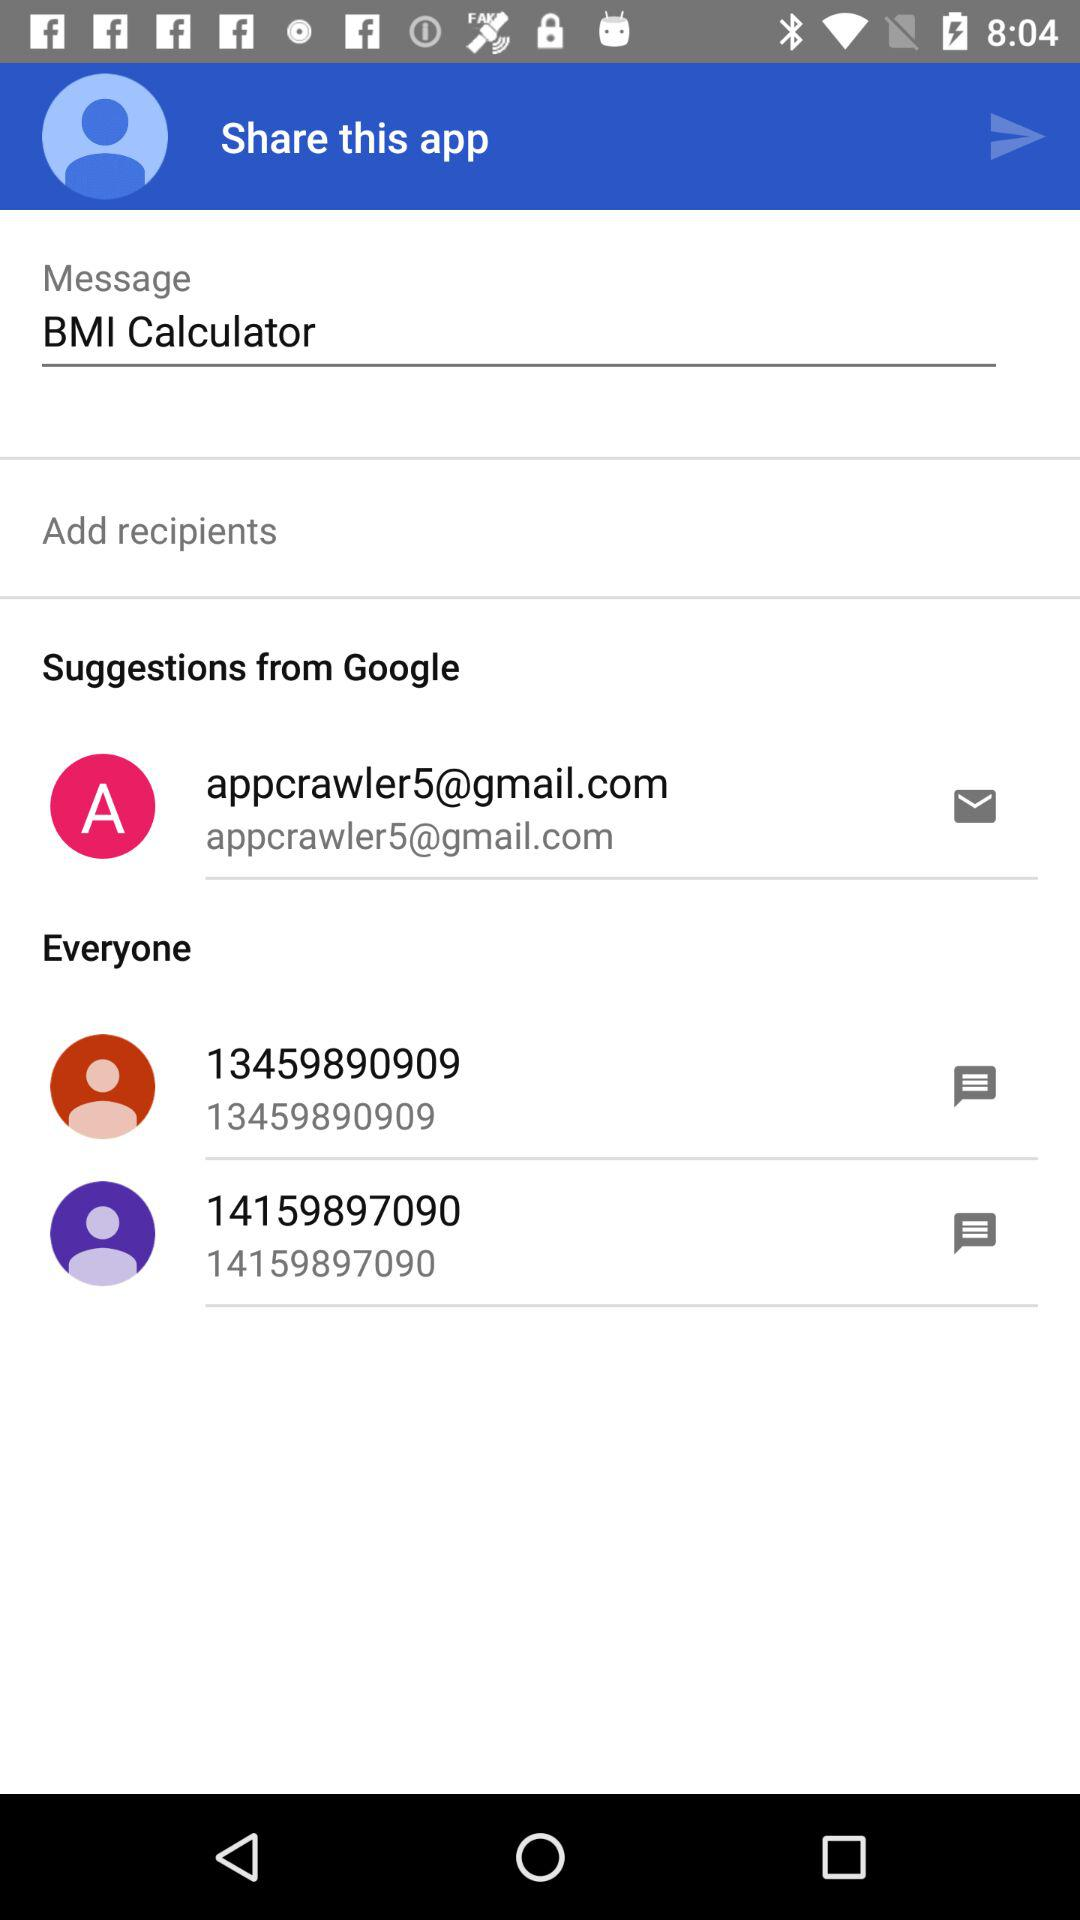What is the email address? The email address is appcrawler5@gmail.com. 